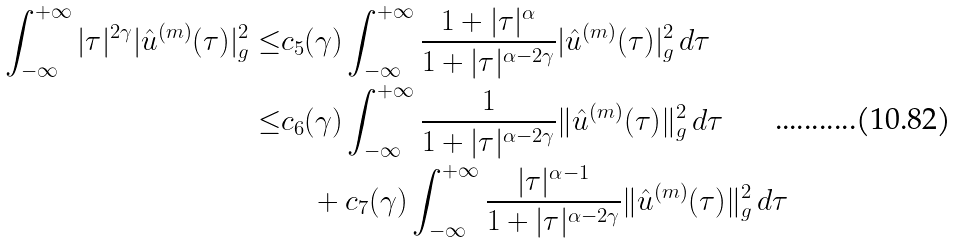<formula> <loc_0><loc_0><loc_500><loc_500>\int _ { - \infty } ^ { + \infty } | \tau | ^ { 2 \gamma } | \hat { u } ^ { ( m ) } ( \tau ) | ^ { 2 } _ { g } \leq & c _ { 5 } ( \gamma ) \int _ { - \infty } ^ { + \infty } \frac { 1 + | \tau | ^ { \alpha } } { 1 + | \tau | ^ { \alpha - 2 \gamma } } | \hat { u } ^ { ( m ) } ( \tau ) | ^ { 2 } _ { g } \, d \tau \\ \leq & c _ { 6 } ( \gamma ) \int _ { - \infty } ^ { + \infty } \frac { 1 } { 1 + | \tau | ^ { \alpha - 2 \gamma } } \| \hat { u } ^ { ( m ) } ( \tau ) \| ^ { 2 } _ { g } \, d \tau \\ & \quad + c _ { 7 } ( \gamma ) \int _ { - \infty } ^ { + \infty } \frac { | \tau | ^ { \alpha - 1 } } { 1 + | \tau | ^ { \alpha - 2 \gamma } } \| \hat { u } ^ { ( m ) } ( \tau ) \| ^ { 2 } _ { g } \, d \tau</formula> 